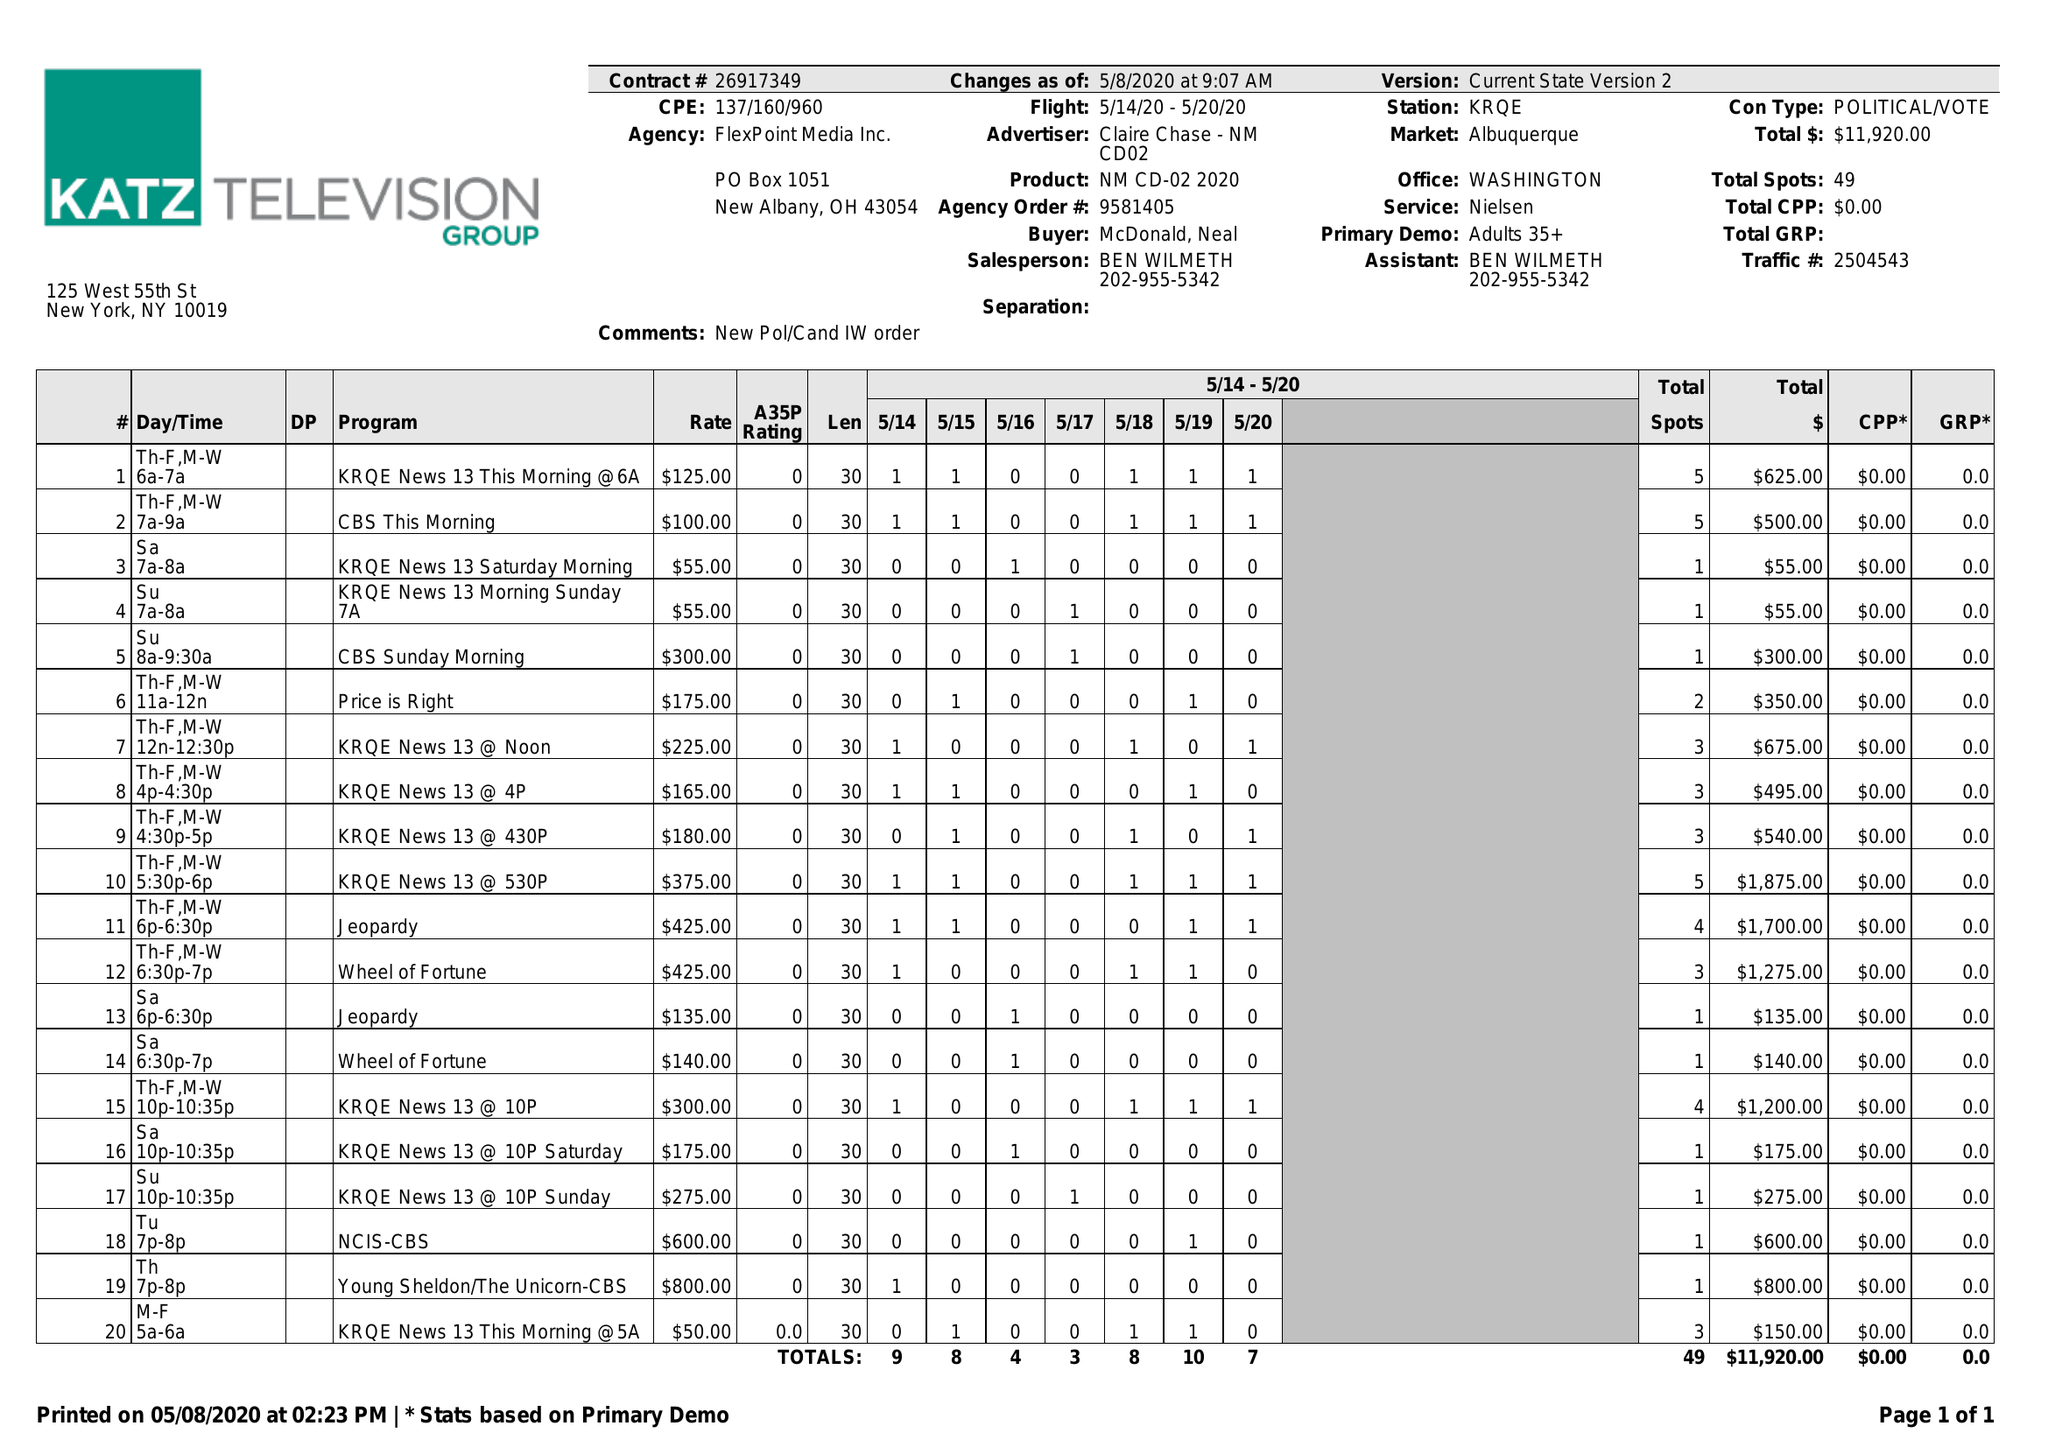What is the value for the advertiser?
Answer the question using a single word or phrase. CLAIRE CHASE - NM CD02 